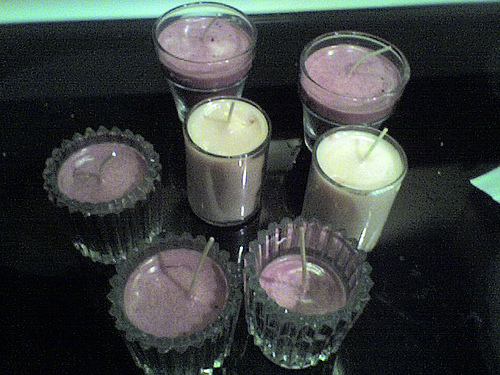<image>
Is there a white candle to the left of the purple candle? No. The white candle is not to the left of the purple candle. From this viewpoint, they have a different horizontal relationship. Is the candle next to the candle? No. The candle is not positioned next to the candle. They are located in different areas of the scene. 